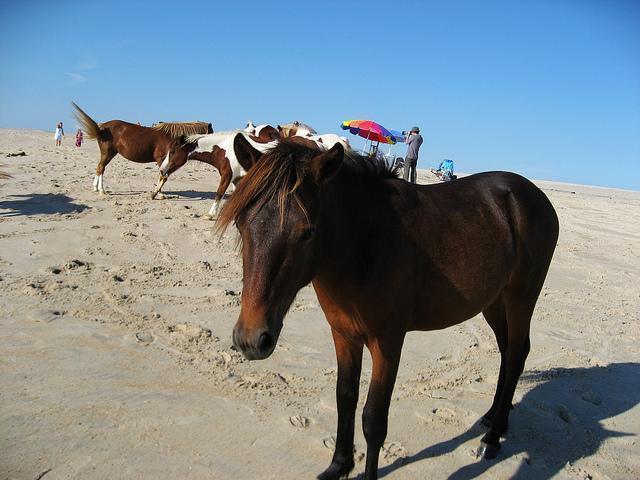How many horses are countable on the beach?
Choose the right answer from the provided options to respond to the question.
Options: Four, two, three, five. Five. 